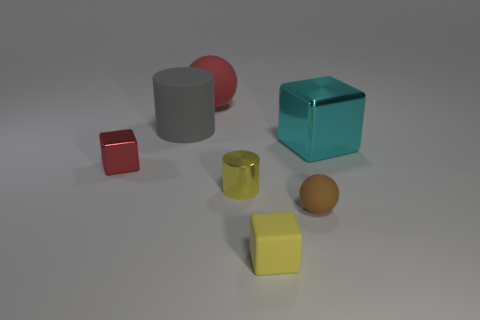There is a brown ball; are there any spheres in front of it?
Your answer should be very brief. No. Do the tiny red block and the tiny thing in front of the tiny brown sphere have the same material?
Provide a short and direct response. No. There is a small object left of the small yellow cylinder; is it the same shape as the brown object?
Ensure brevity in your answer.  No. How many tiny cylinders have the same material as the small red block?
Give a very brief answer. 1. How many objects are small objects that are in front of the yellow shiny thing or large brown metallic balls?
Ensure brevity in your answer.  2. The cyan metal thing is what size?
Keep it short and to the point. Large. What is the cylinder on the right side of the object that is behind the large gray matte object made of?
Your response must be concise. Metal. Does the red thing that is behind the red metallic object have the same size as the cyan metallic thing?
Provide a succinct answer. Yes. Are there any metal blocks that have the same color as the metallic cylinder?
Keep it short and to the point. No. What number of things are either cyan cubes in front of the gray cylinder or metallic objects that are on the left side of the large red rubber thing?
Your response must be concise. 2. 